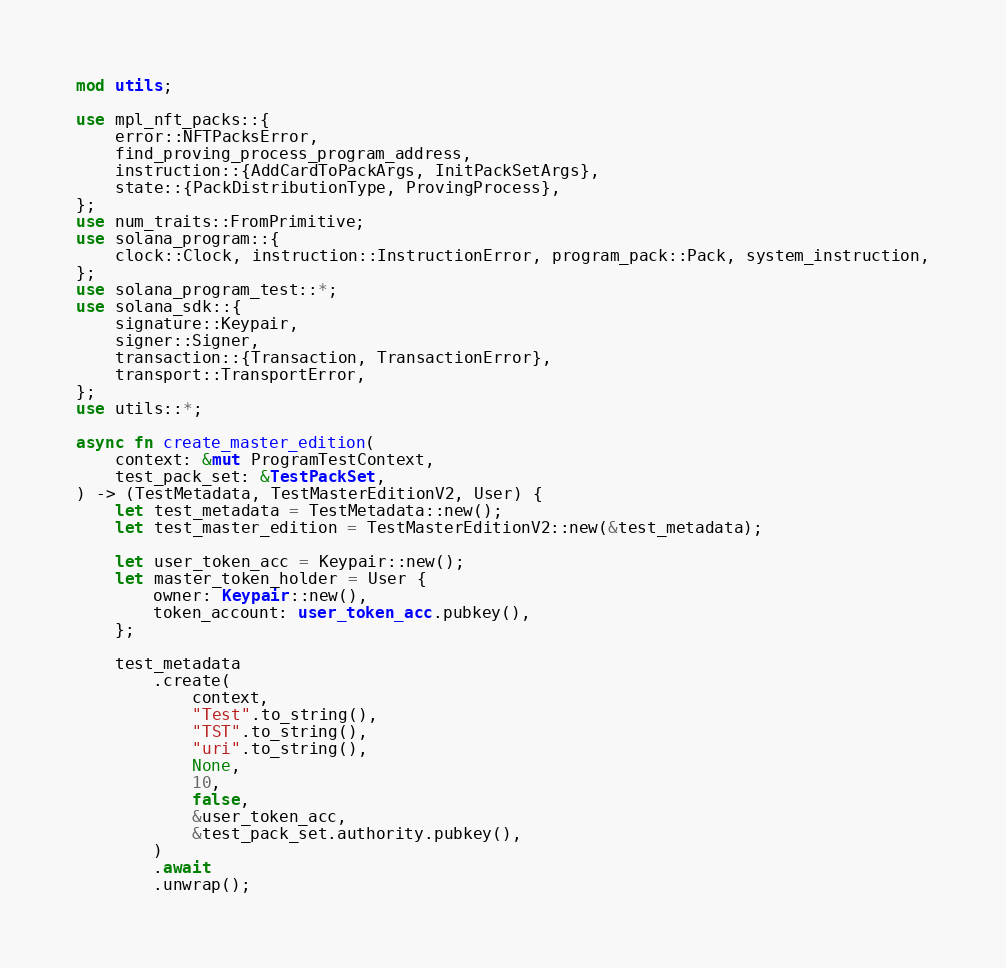<code> <loc_0><loc_0><loc_500><loc_500><_Rust_>mod utils;

use mpl_nft_packs::{
    error::NFTPacksError,
    find_proving_process_program_address,
    instruction::{AddCardToPackArgs, InitPackSetArgs},
    state::{PackDistributionType, ProvingProcess},
};
use num_traits::FromPrimitive;
use solana_program::{
    clock::Clock, instruction::InstructionError, program_pack::Pack, system_instruction,
};
use solana_program_test::*;
use solana_sdk::{
    signature::Keypair,
    signer::Signer,
    transaction::{Transaction, TransactionError},
    transport::TransportError,
};
use utils::*;

async fn create_master_edition(
    context: &mut ProgramTestContext,
    test_pack_set: &TestPackSet,
) -> (TestMetadata, TestMasterEditionV2, User) {
    let test_metadata = TestMetadata::new();
    let test_master_edition = TestMasterEditionV2::new(&test_metadata);

    let user_token_acc = Keypair::new();
    let master_token_holder = User {
        owner: Keypair::new(),
        token_account: user_token_acc.pubkey(),
    };

    test_metadata
        .create(
            context,
            "Test".to_string(),
            "TST".to_string(),
            "uri".to_string(),
            None,
            10,
            false,
            &user_token_acc,
            &test_pack_set.authority.pubkey(),
        )
        .await
        .unwrap();
</code> 